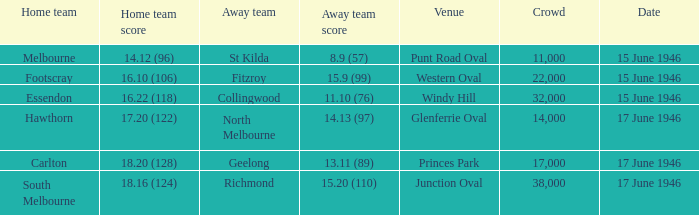On what date did a home team score 16.10 (106)? 15 June 1946. 